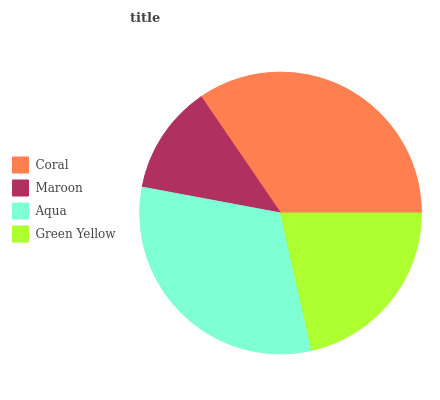Is Maroon the minimum?
Answer yes or no. Yes. Is Coral the maximum?
Answer yes or no. Yes. Is Aqua the minimum?
Answer yes or no. No. Is Aqua the maximum?
Answer yes or no. No. Is Aqua greater than Maroon?
Answer yes or no. Yes. Is Maroon less than Aqua?
Answer yes or no. Yes. Is Maroon greater than Aqua?
Answer yes or no. No. Is Aqua less than Maroon?
Answer yes or no. No. Is Aqua the high median?
Answer yes or no. Yes. Is Green Yellow the low median?
Answer yes or no. Yes. Is Green Yellow the high median?
Answer yes or no. No. Is Aqua the low median?
Answer yes or no. No. 